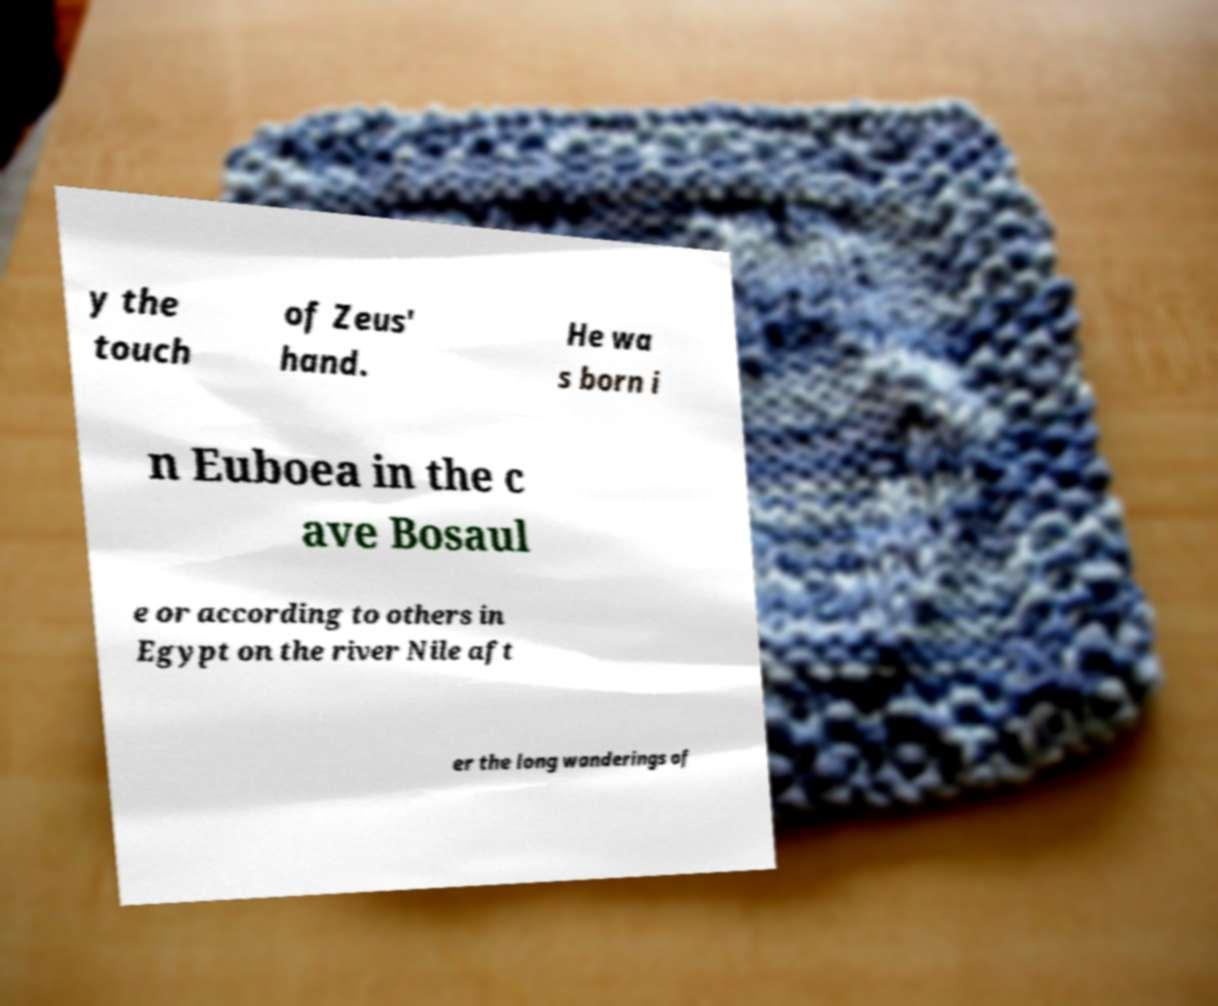I need the written content from this picture converted into text. Can you do that? y the touch of Zeus' hand. He wa s born i n Euboea in the c ave Bosaul e or according to others in Egypt on the river Nile aft er the long wanderings of 